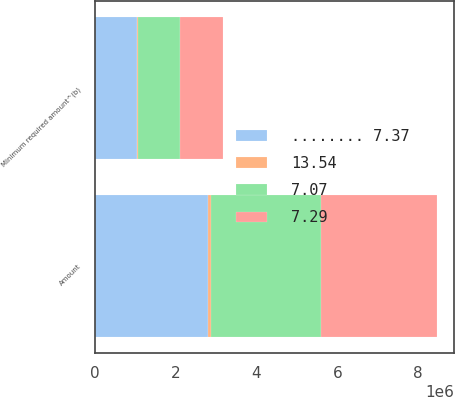<chart> <loc_0><loc_0><loc_500><loc_500><stacked_bar_chart><ecel><fcel>Minimum required amount^(b)<fcel>Amount<nl><fcel>7.29<fcel>1.06588e+06<fcel>2.85769e+06<nl><fcel>7.07<fcel>1.04718e+06<fcel>2.73998e+06<nl><fcel>........ 7.37<fcel>1.04628e+06<fcel>2.79483e+06<nl><fcel>13.54<fcel>20020<fcel>72475<nl></chart> 